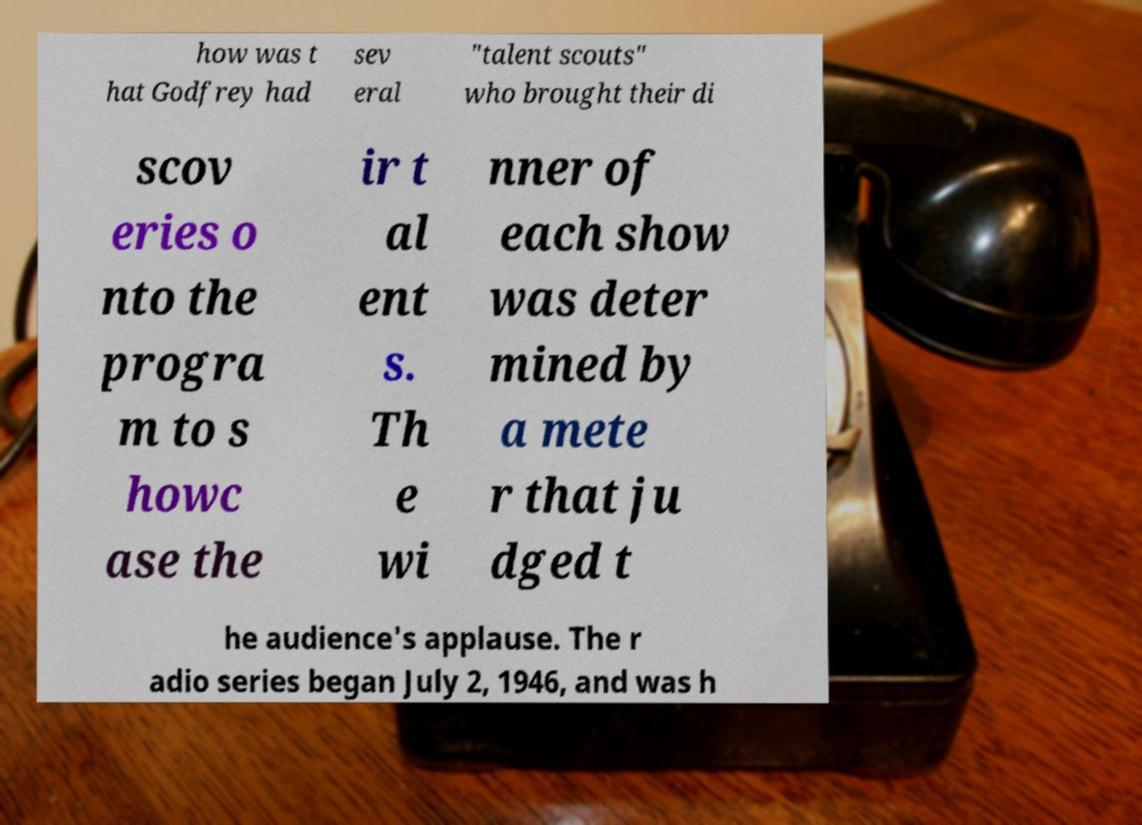For documentation purposes, I need the text within this image transcribed. Could you provide that? how was t hat Godfrey had sev eral "talent scouts" who brought their di scov eries o nto the progra m to s howc ase the ir t al ent s. Th e wi nner of each show was deter mined by a mete r that ju dged t he audience's applause. The r adio series began July 2, 1946, and was h 